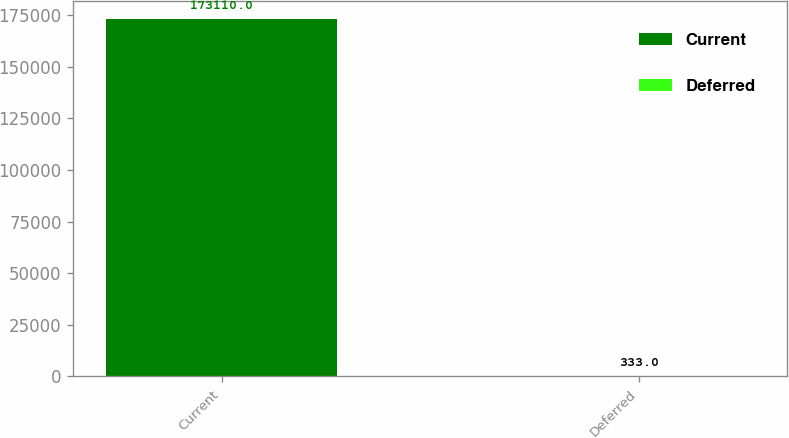Convert chart to OTSL. <chart><loc_0><loc_0><loc_500><loc_500><bar_chart><fcel>Current<fcel>Deferred<nl><fcel>173110<fcel>333<nl></chart> 